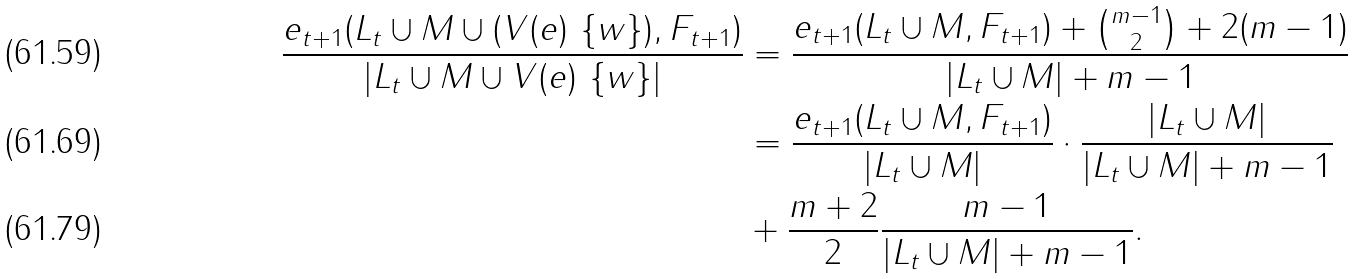Convert formula to latex. <formula><loc_0><loc_0><loc_500><loc_500>\frac { e _ { t + 1 } ( L _ { t } \cup M \cup ( V ( e ) \ \{ w \} ) , F _ { t + 1 } ) } { | L _ { t } \cup M \cup V ( e ) \ \{ w \} | } & = \frac { e _ { t + 1 } ( L _ { t } \cup M , F _ { t + 1 } ) + \binom { m - 1 } { 2 } + 2 ( m - 1 ) } { | L _ { t } \cup M | + m - 1 } \\ & = \frac { e _ { t + 1 } ( L _ { t } \cup M , F _ { t + 1 } ) } { | L _ { t } \cup M | } \cdot \frac { | L _ { t } \cup M | } { | L _ { t } \cup M | + m - 1 } \\ & + \frac { m + 2 } { 2 } \frac { m - 1 } { | L _ { t } \cup M | + m - 1 } .</formula> 